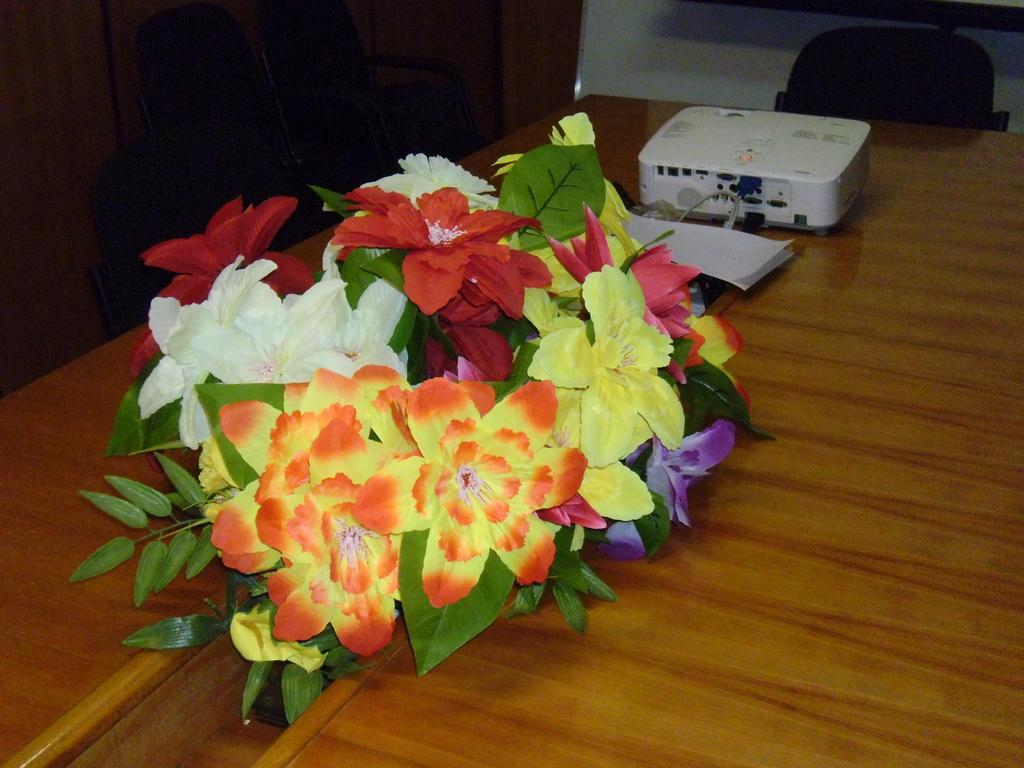What type of natural elements can be seen in the image? There are flowers and leaves in the image. What man-made objects are present in the image? There are papers and a projector on the table in the image. What type of furniture is visible in the background of the image? There are chairs in the background of the image. Are there any other objects visible in the background of the image? Yes, there are other objects in the background of the image. Can you see a tub filled with water in the image? No, there is no tub filled with water in the image. Is there a whip being used in the image? No, there is no whip being used in the image. 